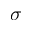<formula> <loc_0><loc_0><loc_500><loc_500>\sigma</formula> 